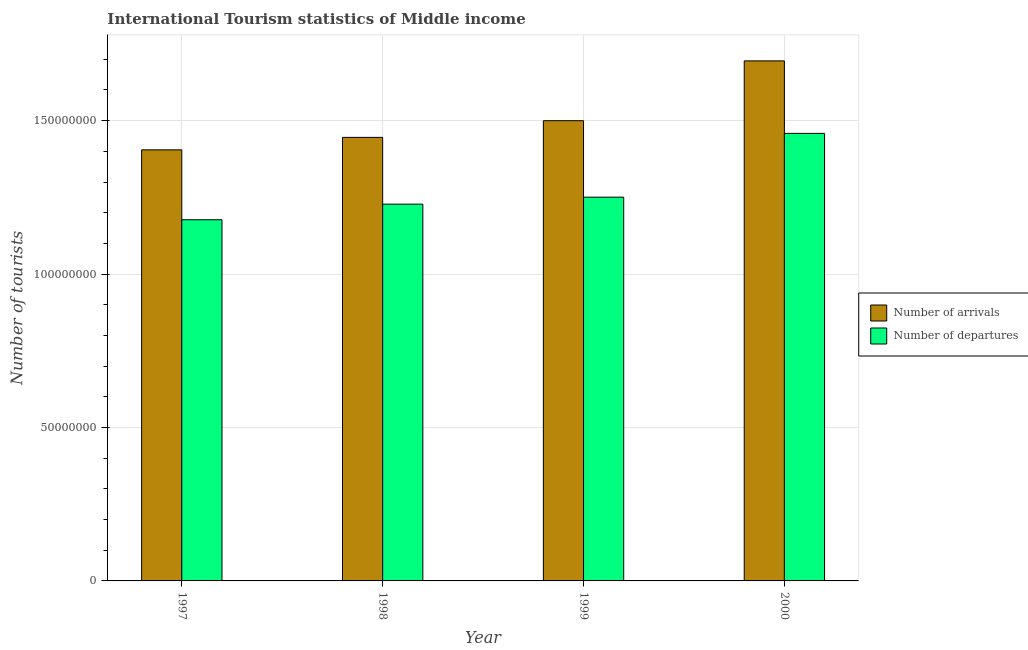How many different coloured bars are there?
Offer a very short reply. 2. Are the number of bars per tick equal to the number of legend labels?
Your answer should be very brief. Yes. Are the number of bars on each tick of the X-axis equal?
Your response must be concise. Yes. How many bars are there on the 4th tick from the right?
Ensure brevity in your answer.  2. What is the label of the 1st group of bars from the left?
Give a very brief answer. 1997. What is the number of tourist departures in 1998?
Your response must be concise. 1.23e+08. Across all years, what is the maximum number of tourist departures?
Give a very brief answer. 1.46e+08. Across all years, what is the minimum number of tourist arrivals?
Your answer should be very brief. 1.40e+08. What is the total number of tourist departures in the graph?
Ensure brevity in your answer.  5.11e+08. What is the difference between the number of tourist departures in 1997 and that in 2000?
Make the answer very short. -2.81e+07. What is the difference between the number of tourist arrivals in 1997 and the number of tourist departures in 1999?
Your response must be concise. -9.49e+06. What is the average number of tourist departures per year?
Keep it short and to the point. 1.28e+08. In the year 1998, what is the difference between the number of tourist departures and number of tourist arrivals?
Your answer should be compact. 0. In how many years, is the number of tourist departures greater than 40000000?
Make the answer very short. 4. What is the ratio of the number of tourist departures in 1997 to that in 1999?
Provide a short and direct response. 0.94. Is the number of tourist arrivals in 1999 less than that in 2000?
Provide a short and direct response. Yes. What is the difference between the highest and the second highest number of tourist departures?
Offer a very short reply. 2.08e+07. What is the difference between the highest and the lowest number of tourist arrivals?
Offer a very short reply. 2.90e+07. In how many years, is the number of tourist arrivals greater than the average number of tourist arrivals taken over all years?
Ensure brevity in your answer.  1. Is the sum of the number of tourist departures in 1997 and 1998 greater than the maximum number of tourist arrivals across all years?
Provide a succinct answer. Yes. What does the 1st bar from the left in 2000 represents?
Offer a terse response. Number of arrivals. What does the 2nd bar from the right in 2000 represents?
Provide a short and direct response. Number of arrivals. How many bars are there?
Provide a short and direct response. 8. Are all the bars in the graph horizontal?
Your answer should be compact. No. What is the difference between two consecutive major ticks on the Y-axis?
Your response must be concise. 5.00e+07. Are the values on the major ticks of Y-axis written in scientific E-notation?
Offer a terse response. No. Does the graph contain any zero values?
Your answer should be compact. No. Does the graph contain grids?
Make the answer very short. Yes. What is the title of the graph?
Offer a very short reply. International Tourism statistics of Middle income. Does "Food" appear as one of the legend labels in the graph?
Provide a succinct answer. No. What is the label or title of the X-axis?
Give a very brief answer. Year. What is the label or title of the Y-axis?
Provide a short and direct response. Number of tourists. What is the Number of tourists of Number of arrivals in 1997?
Provide a succinct answer. 1.40e+08. What is the Number of tourists of Number of departures in 1997?
Keep it short and to the point. 1.18e+08. What is the Number of tourists in Number of arrivals in 1998?
Keep it short and to the point. 1.45e+08. What is the Number of tourists of Number of departures in 1998?
Keep it short and to the point. 1.23e+08. What is the Number of tourists of Number of arrivals in 1999?
Ensure brevity in your answer.  1.50e+08. What is the Number of tourists of Number of departures in 1999?
Offer a terse response. 1.25e+08. What is the Number of tourists in Number of arrivals in 2000?
Provide a short and direct response. 1.69e+08. What is the Number of tourists of Number of departures in 2000?
Your answer should be compact. 1.46e+08. Across all years, what is the maximum Number of tourists of Number of arrivals?
Make the answer very short. 1.69e+08. Across all years, what is the maximum Number of tourists of Number of departures?
Provide a short and direct response. 1.46e+08. Across all years, what is the minimum Number of tourists in Number of arrivals?
Provide a short and direct response. 1.40e+08. Across all years, what is the minimum Number of tourists of Number of departures?
Your answer should be compact. 1.18e+08. What is the total Number of tourists in Number of arrivals in the graph?
Ensure brevity in your answer.  6.04e+08. What is the total Number of tourists in Number of departures in the graph?
Make the answer very short. 5.11e+08. What is the difference between the Number of tourists of Number of arrivals in 1997 and that in 1998?
Offer a very short reply. -4.06e+06. What is the difference between the Number of tourists of Number of departures in 1997 and that in 1998?
Ensure brevity in your answer.  -5.08e+06. What is the difference between the Number of tourists of Number of arrivals in 1997 and that in 1999?
Offer a very short reply. -9.49e+06. What is the difference between the Number of tourists in Number of departures in 1997 and that in 1999?
Give a very brief answer. -7.36e+06. What is the difference between the Number of tourists of Number of arrivals in 1997 and that in 2000?
Ensure brevity in your answer.  -2.90e+07. What is the difference between the Number of tourists of Number of departures in 1997 and that in 2000?
Your response must be concise. -2.81e+07. What is the difference between the Number of tourists in Number of arrivals in 1998 and that in 1999?
Provide a succinct answer. -5.44e+06. What is the difference between the Number of tourists in Number of departures in 1998 and that in 1999?
Offer a terse response. -2.28e+06. What is the difference between the Number of tourists of Number of arrivals in 1998 and that in 2000?
Your response must be concise. -2.49e+07. What is the difference between the Number of tourists in Number of departures in 1998 and that in 2000?
Provide a succinct answer. -2.31e+07. What is the difference between the Number of tourists of Number of arrivals in 1999 and that in 2000?
Your answer should be compact. -1.95e+07. What is the difference between the Number of tourists in Number of departures in 1999 and that in 2000?
Keep it short and to the point. -2.08e+07. What is the difference between the Number of tourists of Number of arrivals in 1997 and the Number of tourists of Number of departures in 1998?
Your answer should be very brief. 1.77e+07. What is the difference between the Number of tourists of Number of arrivals in 1997 and the Number of tourists of Number of departures in 1999?
Make the answer very short. 1.54e+07. What is the difference between the Number of tourists of Number of arrivals in 1997 and the Number of tourists of Number of departures in 2000?
Ensure brevity in your answer.  -5.36e+06. What is the difference between the Number of tourists of Number of arrivals in 1998 and the Number of tourists of Number of departures in 1999?
Your answer should be very brief. 1.95e+07. What is the difference between the Number of tourists in Number of arrivals in 1998 and the Number of tourists in Number of departures in 2000?
Offer a very short reply. -1.31e+06. What is the difference between the Number of tourists in Number of arrivals in 1999 and the Number of tourists in Number of departures in 2000?
Give a very brief answer. 4.13e+06. What is the average Number of tourists in Number of arrivals per year?
Offer a very short reply. 1.51e+08. What is the average Number of tourists in Number of departures per year?
Keep it short and to the point. 1.28e+08. In the year 1997, what is the difference between the Number of tourists in Number of arrivals and Number of tourists in Number of departures?
Provide a succinct answer. 2.28e+07. In the year 1998, what is the difference between the Number of tourists in Number of arrivals and Number of tourists in Number of departures?
Offer a very short reply. 2.18e+07. In the year 1999, what is the difference between the Number of tourists of Number of arrivals and Number of tourists of Number of departures?
Offer a terse response. 2.49e+07. In the year 2000, what is the difference between the Number of tourists in Number of arrivals and Number of tourists in Number of departures?
Offer a very short reply. 2.36e+07. What is the ratio of the Number of tourists of Number of arrivals in 1997 to that in 1998?
Make the answer very short. 0.97. What is the ratio of the Number of tourists of Number of departures in 1997 to that in 1998?
Offer a terse response. 0.96. What is the ratio of the Number of tourists of Number of arrivals in 1997 to that in 1999?
Your answer should be very brief. 0.94. What is the ratio of the Number of tourists of Number of arrivals in 1997 to that in 2000?
Your response must be concise. 0.83. What is the ratio of the Number of tourists of Number of departures in 1997 to that in 2000?
Ensure brevity in your answer.  0.81. What is the ratio of the Number of tourists of Number of arrivals in 1998 to that in 1999?
Offer a very short reply. 0.96. What is the ratio of the Number of tourists of Number of departures in 1998 to that in 1999?
Provide a succinct answer. 0.98. What is the ratio of the Number of tourists in Number of arrivals in 1998 to that in 2000?
Your answer should be very brief. 0.85. What is the ratio of the Number of tourists of Number of departures in 1998 to that in 2000?
Provide a succinct answer. 0.84. What is the ratio of the Number of tourists of Number of arrivals in 1999 to that in 2000?
Your answer should be very brief. 0.89. What is the ratio of the Number of tourists in Number of departures in 1999 to that in 2000?
Your response must be concise. 0.86. What is the difference between the highest and the second highest Number of tourists in Number of arrivals?
Offer a very short reply. 1.95e+07. What is the difference between the highest and the second highest Number of tourists of Number of departures?
Provide a short and direct response. 2.08e+07. What is the difference between the highest and the lowest Number of tourists of Number of arrivals?
Your answer should be compact. 2.90e+07. What is the difference between the highest and the lowest Number of tourists in Number of departures?
Keep it short and to the point. 2.81e+07. 